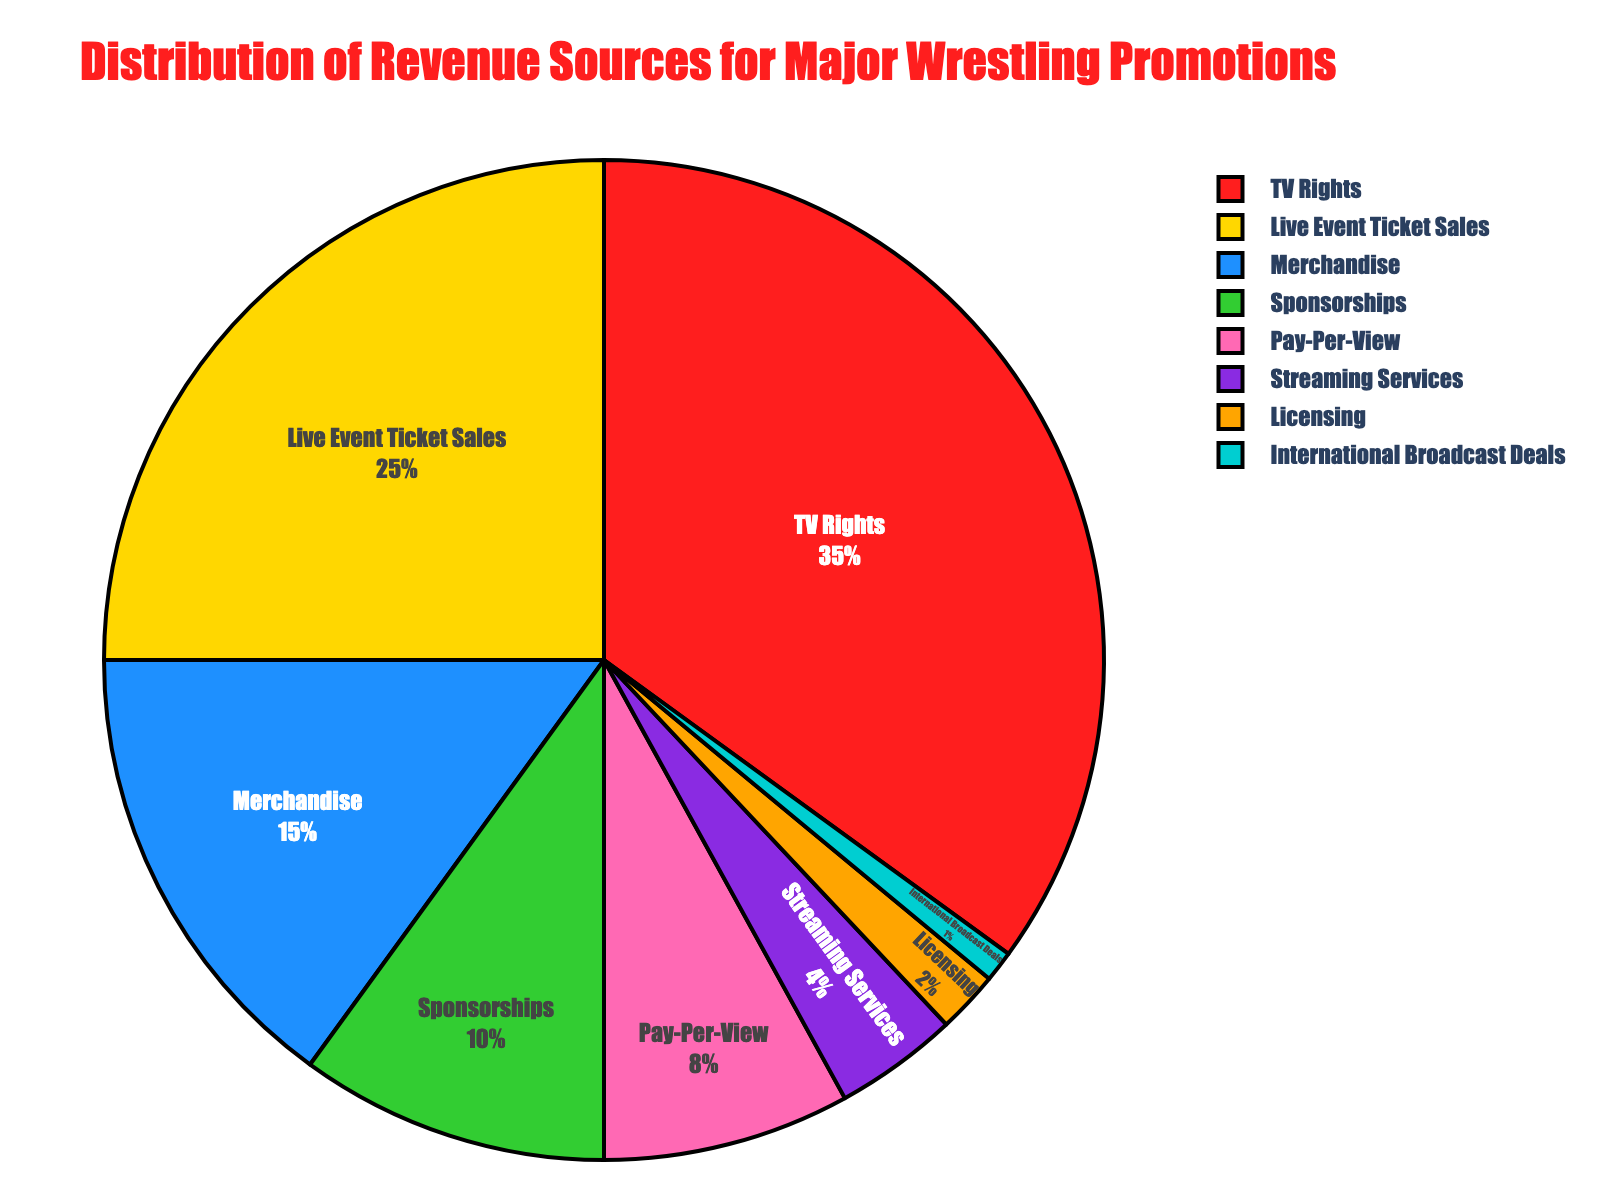How much percentage does TV Rights and Live Event Ticket Sales contribute together? Add the percentages for TV Rights (35%) and Live Event Ticket Sales (25%) to find the total contribution of these two categories: 35% + 25% = 60%
Answer: 60% Which revenue source contributes the least to the overall distribution? Identify the category with the smallest percentage in the pie chart, which is International Broadcast Deals contributing 1%.
Answer: International Broadcast Deals Is the percentage contribution of Merchandise greater than Sponsorships? Compare the percentage for Merchandise (15%) with Sponsorships (10%) to see that Merchandise has a greater contribution.
Answer: Yes What colors are used to represent Pay-Per-View and Streaming Services? Pay-Per-View is labeled with a specific visual color (Pink) and Streaming Services with another color (Purple) on the pie chart. Observe these colors from the chart legend or sections.
Answer: Pink and Purple How much more does TV Rights contribute compared to Pay-Per-View? Find the difference between the percentages for TV Rights (35%) and Pay-Per-View (8%): 35% - 8% = 27%.
Answer: 27% What is the combined contribution of the bottom three categories in the chart? Sum the percentages for the three smallest categories: International Broadcast Deals (1%), Licensing (2%), and Streaming Services (4%): 1% + 2% + 4% = 7%.
Answer: 7% Which revenue source has a mid-range percentage between Live Event Ticket Sales and Sponsorships? Identify the category with a percentage between Live Event Ticket Sales (25%) and Sponsorships (10%). Merchandise has a mid-range percentage of 15%.
Answer: Merchandise Are TV Rights and Live Event Ticket Sales combined more than half of the total revenue distribution? Evaluate if their combined percentage (60%) is greater than 50%. Since 60% is more than 50%, they do contribute more.
Answer: Yes What percentage is represented by the categories other than the top two contributors (TV Rights and Live Event Ticket Sales)? Subtract the combined percentage of the top two contributors from 100%: 100% - (35% + 25%) = 100% - 60% = 40%.
Answer: 40% 